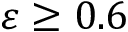<formula> <loc_0><loc_0><loc_500><loc_500>\varepsilon \geq 0 . 6</formula> 